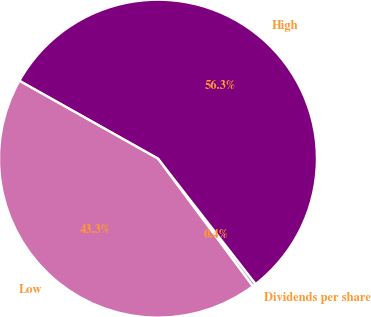Convert chart. <chart><loc_0><loc_0><loc_500><loc_500><pie_chart><fcel>Dividends per share<fcel>High<fcel>Low<nl><fcel>0.35%<fcel>56.32%<fcel>43.32%<nl></chart> 